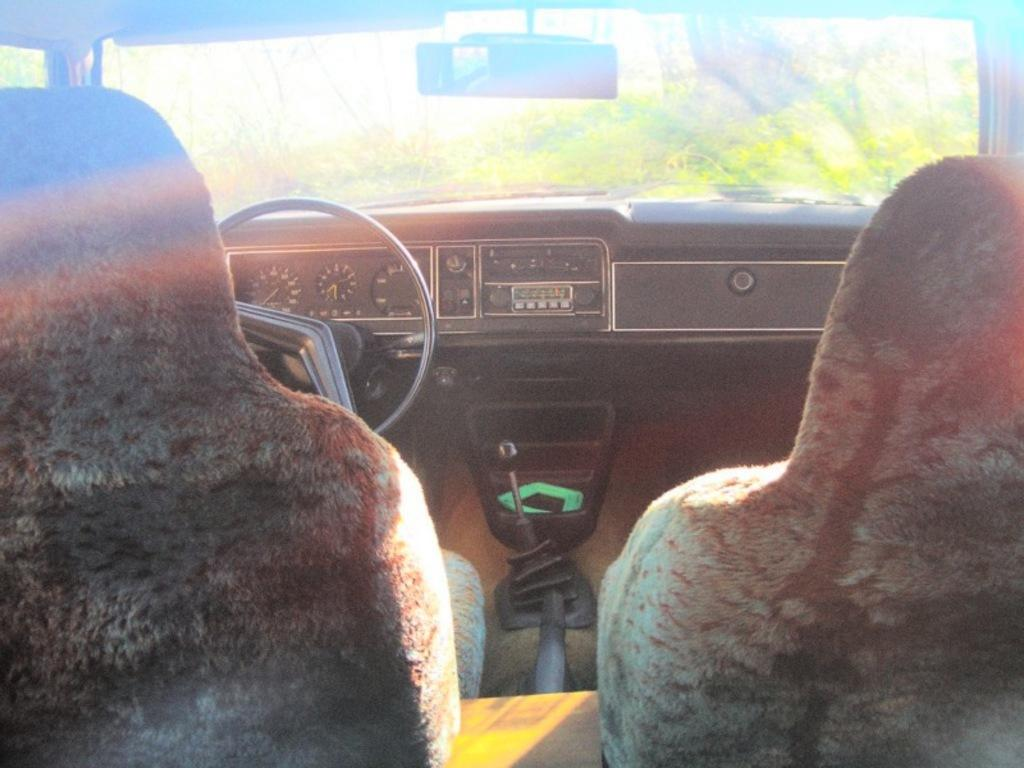What is the setting of the image? The image shows the inside part of a car. What can be found inside the car? There are seats, a speedometer, a steering wheel, and a windscreen visible in the car. What might be used to control the direction of the car? The steering wheel is present in the car for controlling the direction. What is visible through the front of the car? Trees are in front of the car. How many babies are sitting on the comb in the image? There are no babies or combs present in the image. What type of coil is visible in the image? There is no coil visible in the image. 